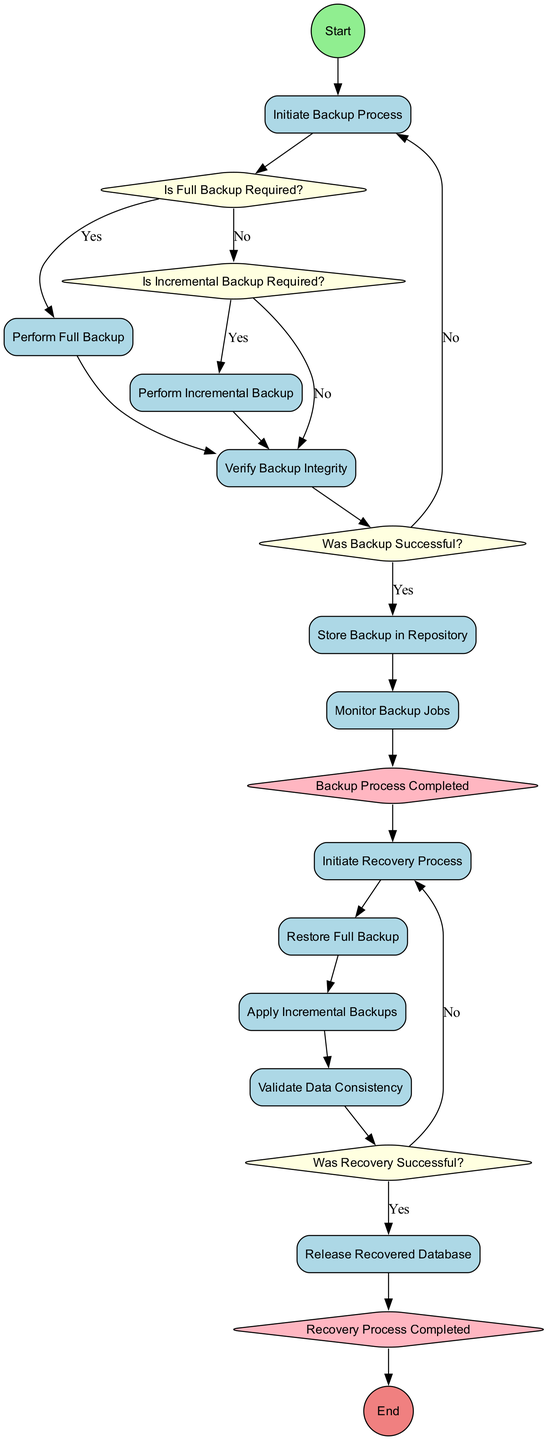What is the initial activity in the backup process? The diagram starts with the "Start" node, which leads to the first activity named "Initiate Backup Process."
Answer: Initiate Backup Process How many activities are there in the backup and recovery process? The diagram contains a total of eleven activities listed under the "activities" section.
Answer: Eleven What decision follows the "Initiate Backup Process"? After initiating the backup process, the next decision node is "Is Full Backup Required?" This is where it determines whether to perform a full backup or move to incremental backup options.
Answer: Is Full Backup Required? What is the outcome if the "Verify Backup Integrity" step fails? If the backup integrity verification fails, the process will return to "Initiate Backup Process" as indicated by the edge connecting those nodes in the diagram.
Answer: Initiate Backup Process What is the last step before the process reaches the end? The final activity before reaching the "End" node is "Release Recovered Database," indicating that the database is restored and ready to be used by users.
Answer: Release Recovered Database How many merge nodes are present in the diagram? The diagram features two merge nodes, namely "Backup Process Completed" and "Recovery Process Completed," indicating the conclusion of the respective processes.
Answer: Two What happens if the "Was Backup Successful?" decision indicates "No"? If the decision "Was Backup Successful?" indicates "No," the flow is directed back to "Initiate Backup Process," prompting a re-attempt to perform the backup process.
Answer: Initiate Backup Process Which activity is directly related to "Apply Incremental Backups"? The activity directly preceding "Apply Incremental Backups" is "Restore Full Backup," indicating that applying incremental backups follows the restoration of a full backup.
Answer: Restore Full Backup 